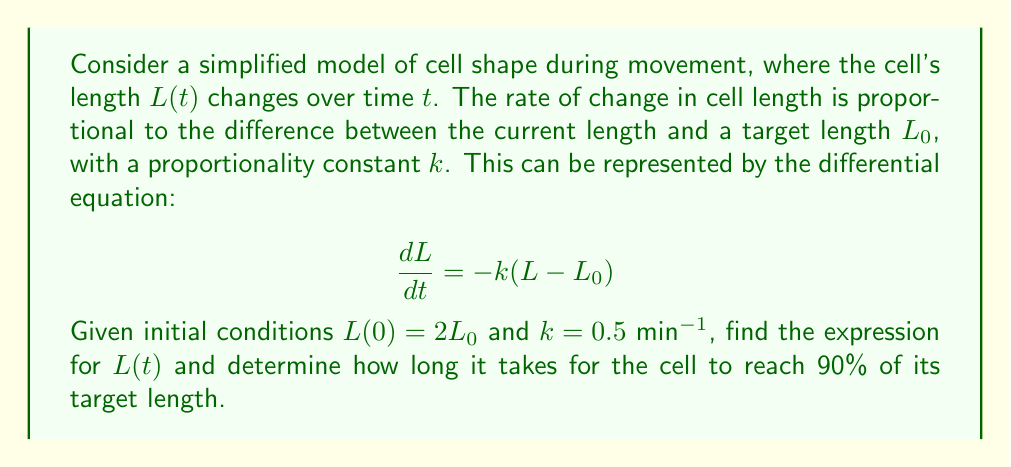Solve this math problem. To solve this differential equation, we follow these steps:

1) First, we rearrange the equation:
   $$\frac{dL}{dt} = -kL + kL_0$$

2) This is a first-order linear differential equation of the form:
   $$\frac{dy}{dx} + P(x)y = Q(x)$$
   where $P(x) = k$ and $Q(x) = kL_0$

3) The general solution for this type of equation is:
   $$y = e^{-\int P(x)dx} \left(\int Q(x)e^{\int P(x)dx}dx + C\right)$$

4) In our case:
   $$L = e^{-kt} \left(\int kL_0e^{kt}dt + C\right)$$

5) Solving the integral:
   $$L = e^{-kt} \left(L_0e^{kt} + C\right) = L_0 + Ce^{-kt}$$

6) Using the initial condition $L(0) = 2L_0$:
   $$2L_0 = L_0 + C$$
   $$C = L_0$$

7) Therefore, the solution is:
   $$L(t) = L_0 + L_0e^{-kt} = L_0(1 + e^{-kt})$$

8) To find when the cell reaches 90% of its target length:
   $$0.9L_0 = L_0(1 + e^{-kt})$$
   $$0.9 = 1 + e^{-kt}$$
   $$e^{-kt} = -0.1$$
   $$-kt = \ln(0.1)$$
   $$t = -\frac{\ln(0.1)}{k} = -\frac{\ln(0.1)}{0.5} \approx 4.605$$ minutes
Answer: The expression for $L(t)$ is $L(t) = L_0(1 + e^{-0.5t})$, and it takes approximately 4.605 minutes for the cell to reach 90% of its target length. 